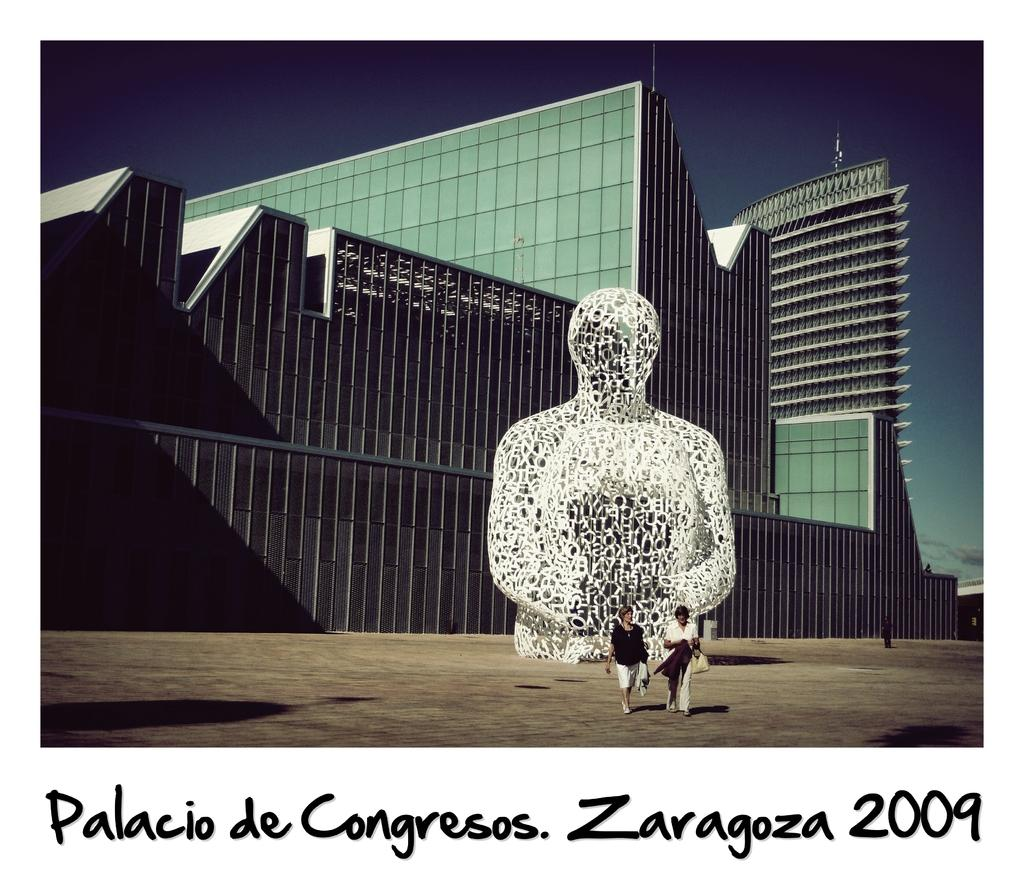<image>
Render a clear and concise summary of the photo. A polaroid of the palacio de congresos in zaragoza. 